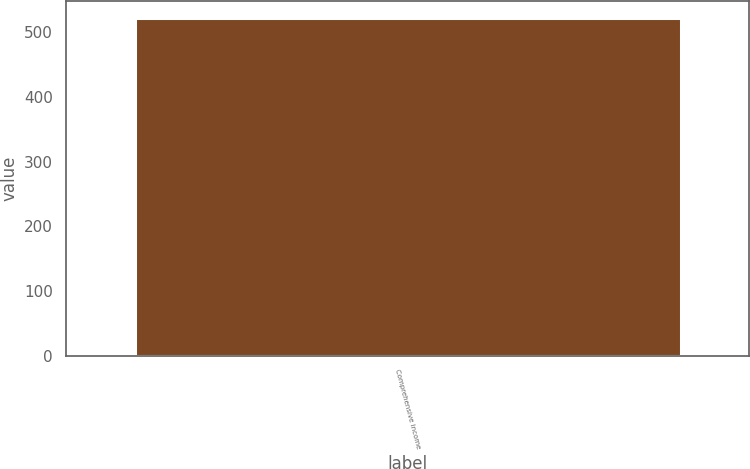<chart> <loc_0><loc_0><loc_500><loc_500><bar_chart><fcel>Comprehensive income<nl><fcel>522<nl></chart> 